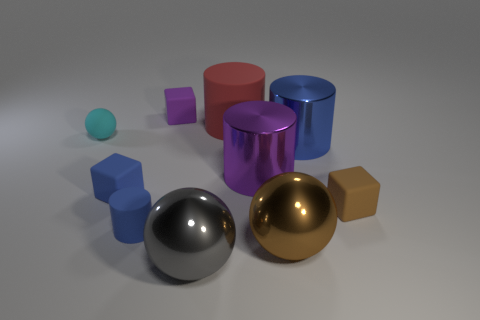Subtract all large balls. How many balls are left? 1 Subtract all purple cylinders. How many cylinders are left? 3 Subtract all yellow cylinders. Subtract all brown cubes. How many cylinders are left? 4 Subtract all spheres. How many objects are left? 7 Add 1 blue cylinders. How many blue cylinders exist? 3 Subtract 1 purple cylinders. How many objects are left? 9 Subtract all large shiny spheres. Subtract all small blue rubber blocks. How many objects are left? 7 Add 1 big purple metal cylinders. How many big purple metal cylinders are left? 2 